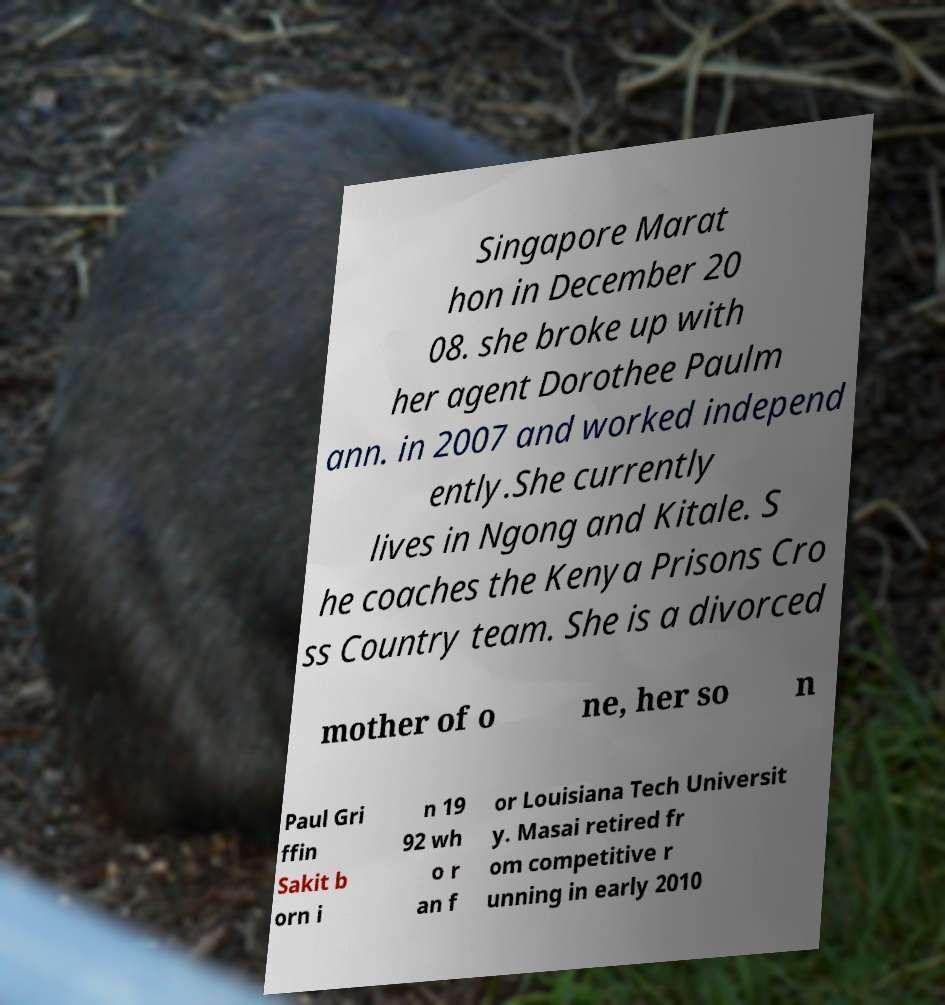There's text embedded in this image that I need extracted. Can you transcribe it verbatim? Singapore Marat hon in December 20 08. she broke up with her agent Dorothee Paulm ann. in 2007 and worked independ ently.She currently lives in Ngong and Kitale. S he coaches the Kenya Prisons Cro ss Country team. She is a divorced mother of o ne, her so n Paul Gri ffin Sakit b orn i n 19 92 wh o r an f or Louisiana Tech Universit y. Masai retired fr om competitive r unning in early 2010 